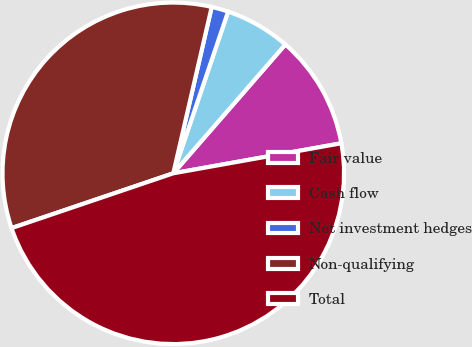Convert chart to OTSL. <chart><loc_0><loc_0><loc_500><loc_500><pie_chart><fcel>Fair value<fcel>Cash flow<fcel>Net investment hedges<fcel>Non-qualifying<fcel>Total<nl><fcel>10.79%<fcel>6.19%<fcel>1.59%<fcel>33.81%<fcel>47.61%<nl></chart> 